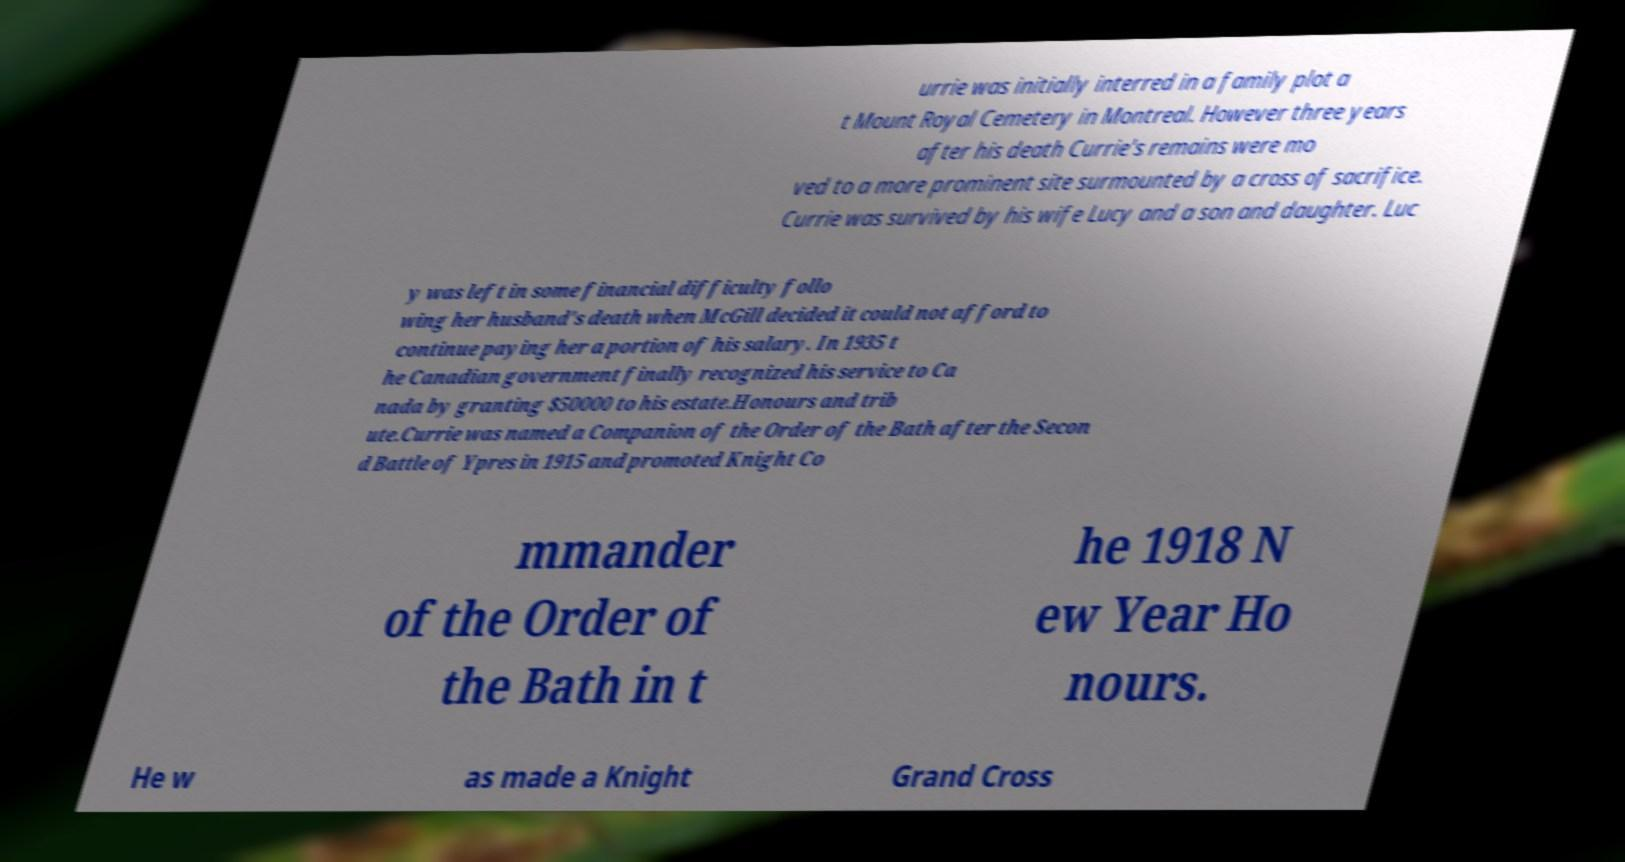Can you read and provide the text displayed in the image?This photo seems to have some interesting text. Can you extract and type it out for me? urrie was initially interred in a family plot a t Mount Royal Cemetery in Montreal. However three years after his death Currie's remains were mo ved to a more prominent site surmounted by a cross of sacrifice. Currie was survived by his wife Lucy and a son and daughter. Luc y was left in some financial difficulty follo wing her husband's death when McGill decided it could not afford to continue paying her a portion of his salary. In 1935 t he Canadian government finally recognized his service to Ca nada by granting $50000 to his estate.Honours and trib ute.Currie was named a Companion of the Order of the Bath after the Secon d Battle of Ypres in 1915 and promoted Knight Co mmander of the Order of the Bath in t he 1918 N ew Year Ho nours. He w as made a Knight Grand Cross 